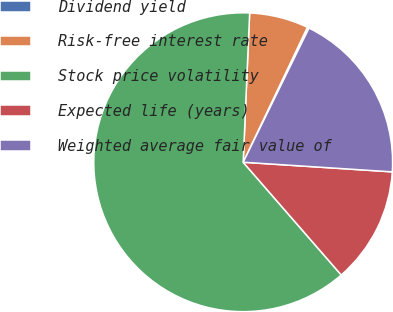Convert chart. <chart><loc_0><loc_0><loc_500><loc_500><pie_chart><fcel>Dividend yield<fcel>Risk-free interest rate<fcel>Stock price volatility<fcel>Expected life (years)<fcel>Weighted average fair value of<nl><fcel>0.19%<fcel>6.38%<fcel>62.09%<fcel>12.58%<fcel>18.77%<nl></chart> 